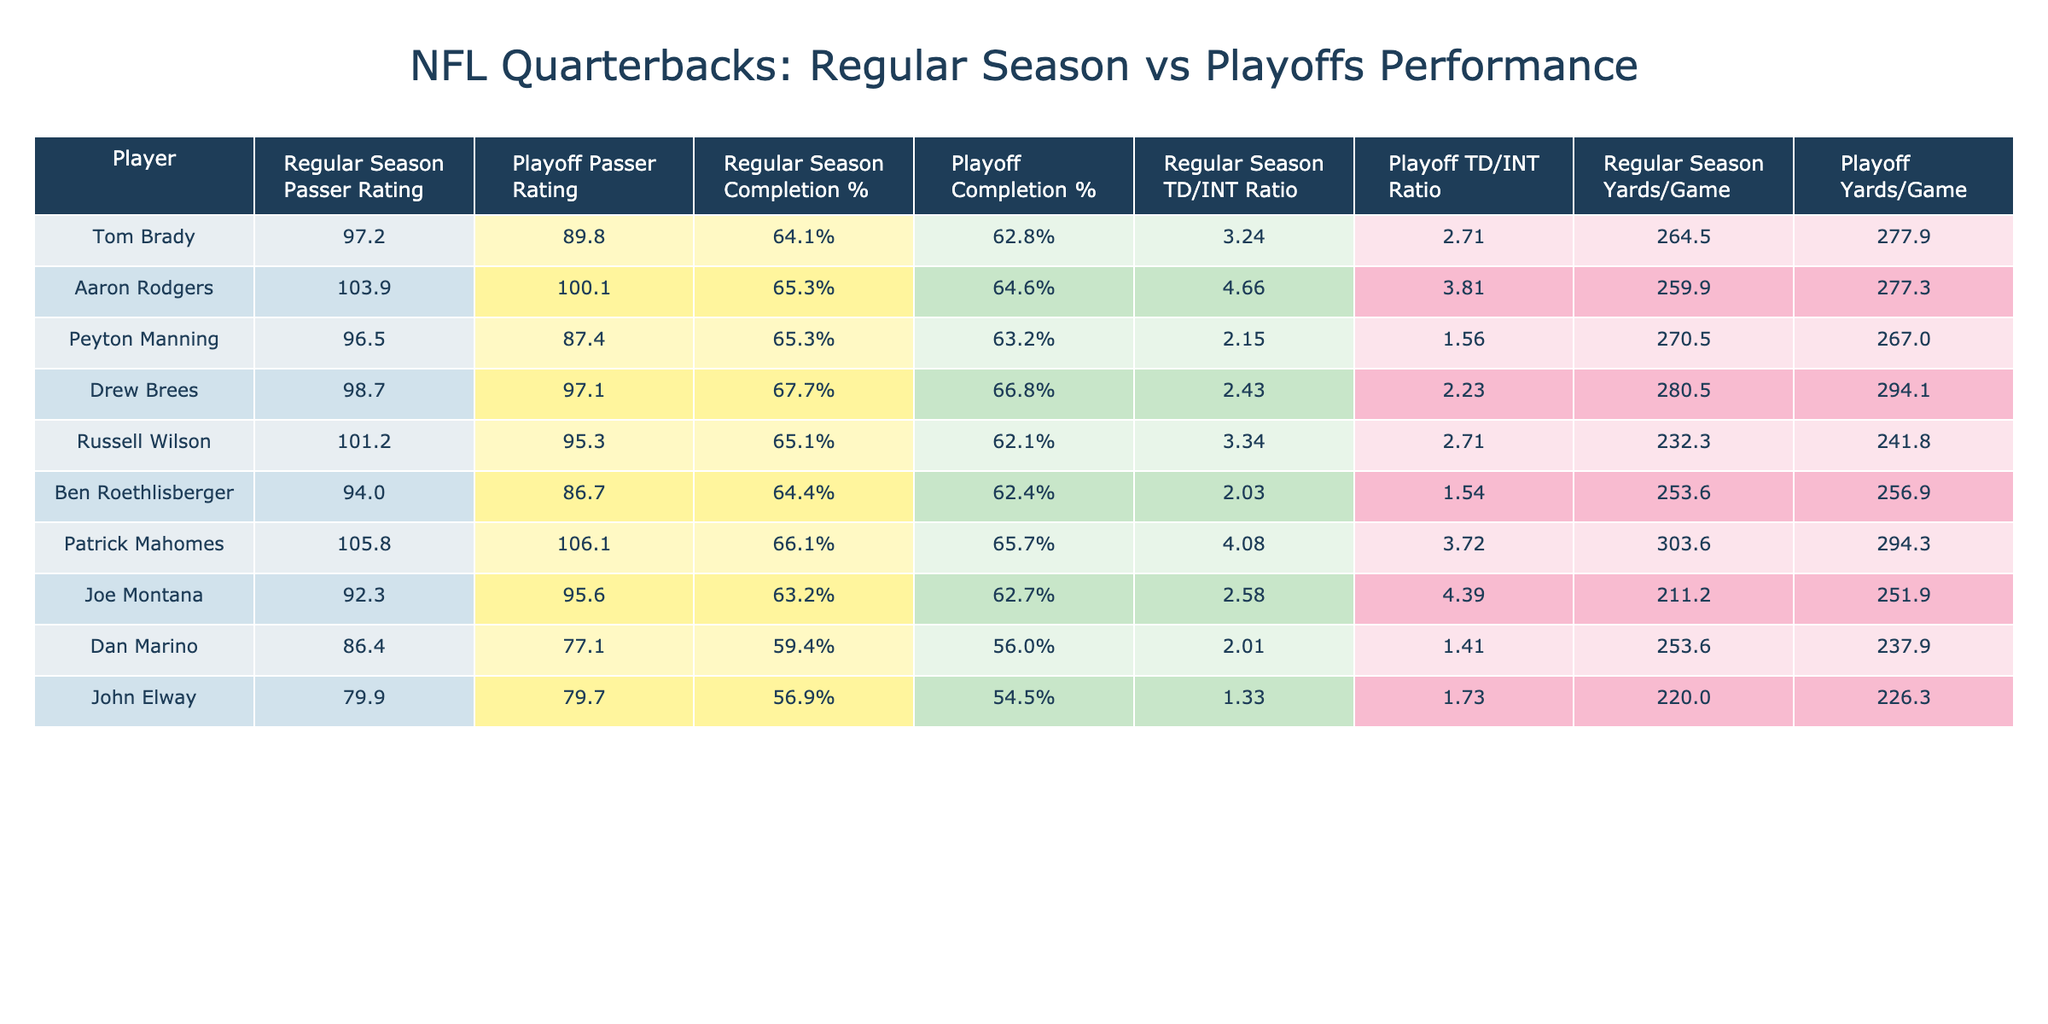What is Tom Brady's regular season passer rating? By referring to the table, we can directly locate Tom Brady in the players list and find his regular season passer rating, which is listed as 97.2.
Answer: 97.2 What is the playoff completion percentage of Drew Brees? Looking at the table, we find Drew Brees and check his playoff completion percentage, which is 66.8%.
Answer: 66.8% Which quarterback had the highest regular season passer rating? In the passer rating section of the table for the regular season, we can see that Patrick Mahomes has the highest value at 105.8.
Answer: Patrick Mahomes What is the difference in the completion percentage between the regular season and playoffs for Aaron Rodgers? First, find the completion percentages for Aaron Rodgers: 65.3% in the regular season and 64.6% in the playoffs. We then subtract the playoff percentage from the regular season percentage: 65.3% - 64.6% = 0.7%.
Answer: 0.7% Did any quarterback's playoff passer rating exceed their regular season passer rating? To answer this, we compare each player's passer ratings for both regular and playoff seasons. Only Patrick Mahomes has a playoff passer rating (106.1) that is higher than his regular season rating (105.8), confirming the statement.
Answer: Yes What is the average yards per game for quarterbacks in the regular season? First, we sum the regular season yards per game for all quarterbacks: (264.5 + 259.9 + 270.5 + 280.5 + 232.3 + 253.6 + 303.6 + 211.2 + 253.6 + 220.0) = 2480.7. There are 10 quarterbacks, so we divide the sum by 10: 2480.7 / 10 = 248.07.
Answer: 248.07 Which quarterback shows the biggest decline in passer rating from the regular season to playoffs? To find this, we calculate the difference in passer rating for each quarterback. The biggest decline is seen in Peyton Manning with a decrease from 96.5 to 87.4, which yields a difference of 9.1.
Answer: Peyton Manning What is the average TD/INT ratio for all quarterbacks during the playoffs? We sum the playoff TD/INT ratios for each quarterback: (2.71 + 3.81 + 1.56 + 2.23 + 2.71 + 1.54 + 3.72 + 4.39 + 1.41 + 1.73) = 23.06. There are 10 quarterbacks, so we divide by 10: 23.06 / 10 = 2.306.
Answer: 2.306 Is Joe Montana's playoff yard per game higher than his regular season yard per game? We look at Joe Montana's stats in the table: he has 211.2 yards/game in the regular season and 251.9 in the playoffs, showing that the playoff yardage exceeds the regular season yardage.
Answer: Yes 